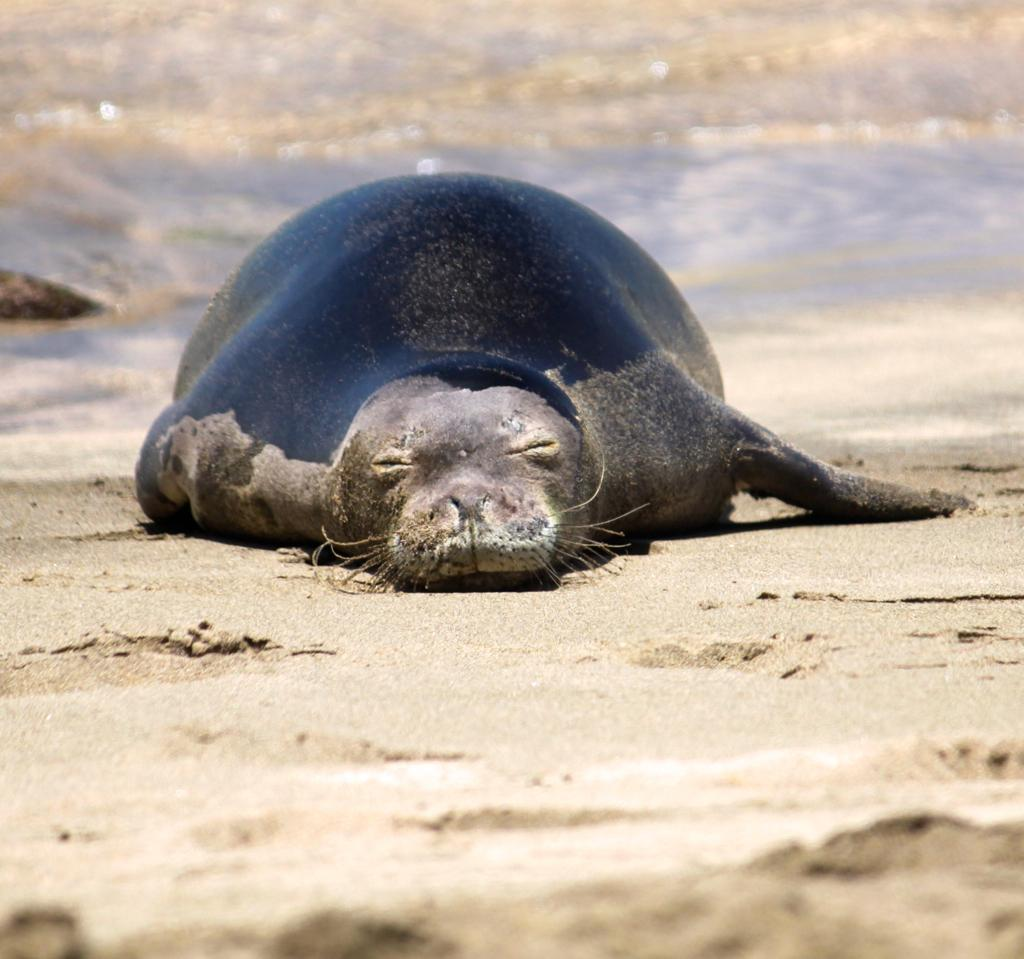What animal is present in the image? There is a seal in the image. What type of surface is the seal resting on? The seal is on sand. What can be seen in the background of the image? There is water visible in the background of the image. What type of nerve can be seen in the image? There is no nerve present in the image; it features a seal on sand with water visible in the background. 